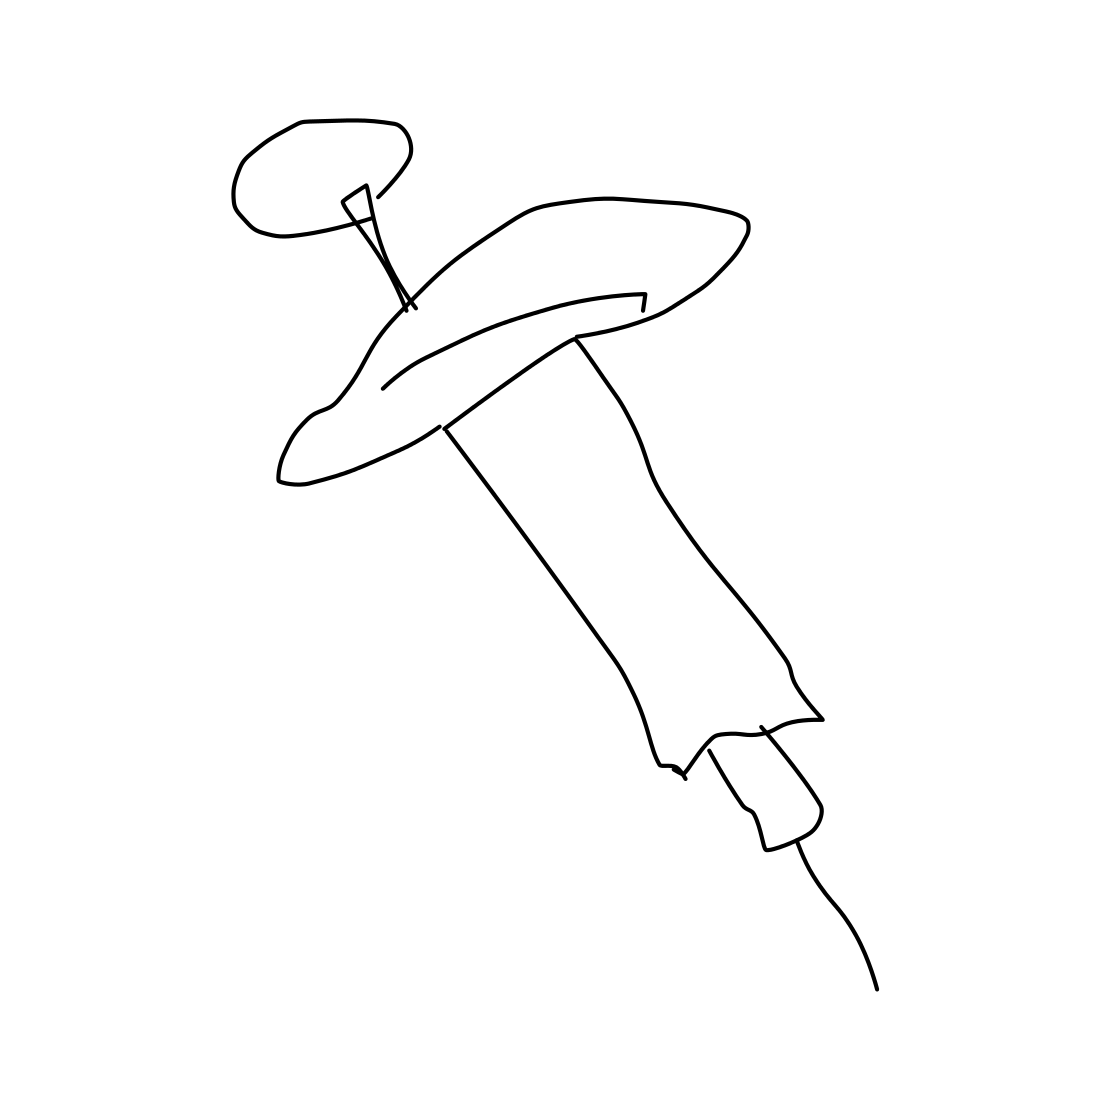What types of medication might be administered with this syringe? This type of syringe could be used for a variety of medications, including vaccines, insulin for diabetes management, or other injectable drugs that require precise dosages. 